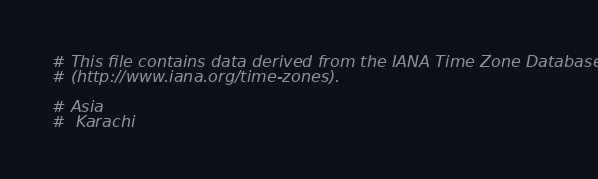Convert code to text. <code><loc_0><loc_0><loc_500><loc_500><_Crystal_># This file contains data derived from the IANA Time Zone Database
# (http://www.iana.org/time-zones).

# Asia
#  Karachi</code> 